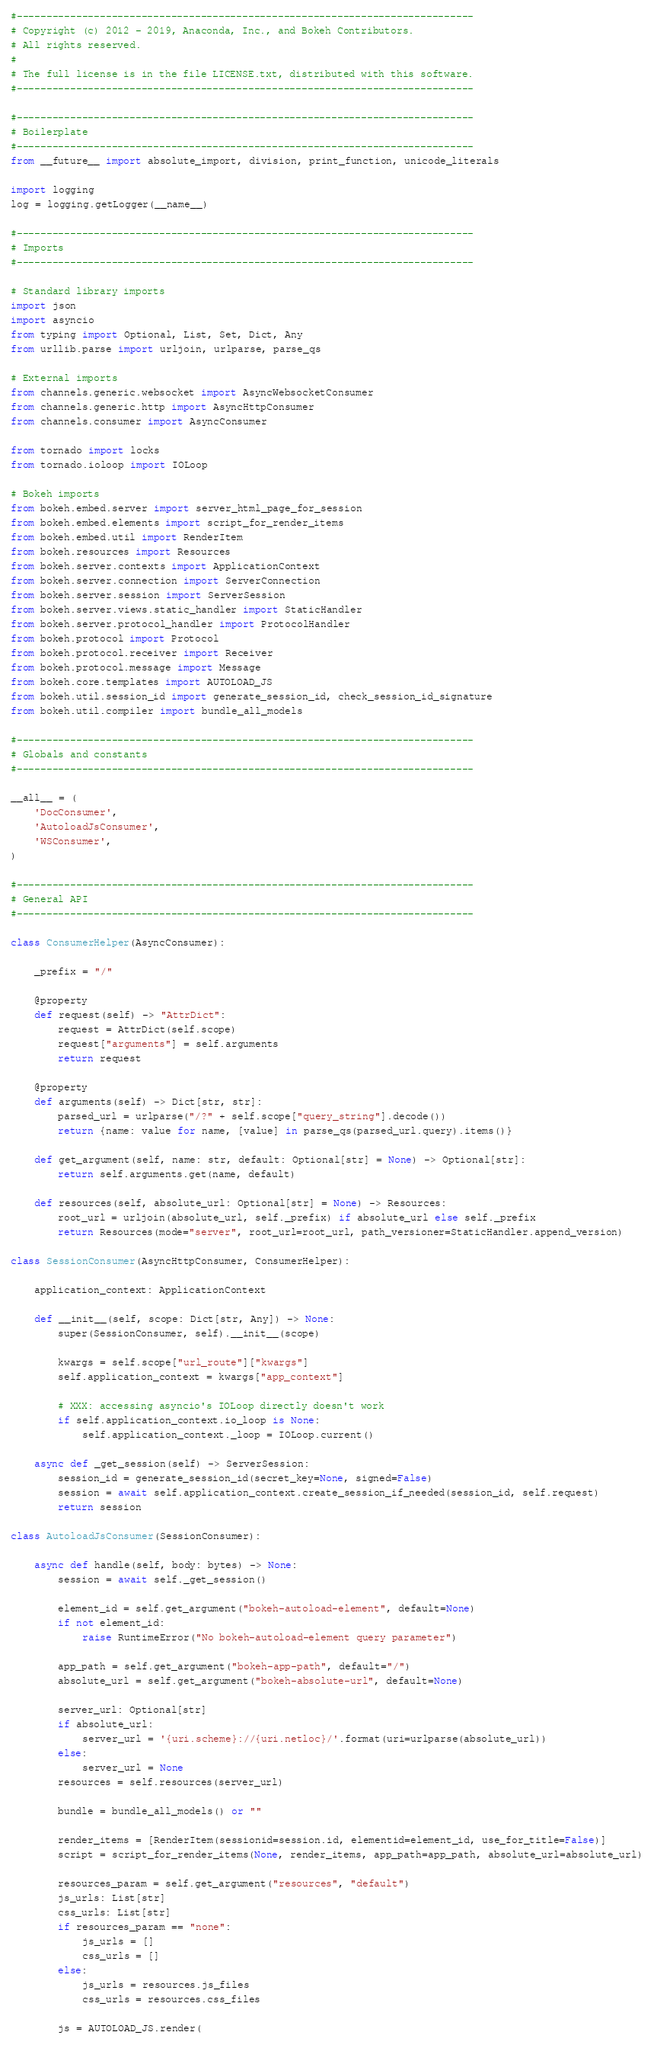Convert code to text. <code><loc_0><loc_0><loc_500><loc_500><_Python_>#-----------------------------------------------------------------------------
# Copyright (c) 2012 - 2019, Anaconda, Inc., and Bokeh Contributors.
# All rights reserved.
#
# The full license is in the file LICENSE.txt, distributed with this software.
#-----------------------------------------------------------------------------

#-----------------------------------------------------------------------------
# Boilerplate
#-----------------------------------------------------------------------------
from __future__ import absolute_import, division, print_function, unicode_literals

import logging
log = logging.getLogger(__name__)

#-----------------------------------------------------------------------------
# Imports
#-----------------------------------------------------------------------------

# Standard library imports
import json
import asyncio
from typing import Optional, List, Set, Dict, Any
from urllib.parse import urljoin, urlparse, parse_qs

# External imports
from channels.generic.websocket import AsyncWebsocketConsumer
from channels.generic.http import AsyncHttpConsumer
from channels.consumer import AsyncConsumer

from tornado import locks
from tornado.ioloop import IOLoop

# Bokeh imports
from bokeh.embed.server import server_html_page_for_session
from bokeh.embed.elements import script_for_render_items
from bokeh.embed.util import RenderItem
from bokeh.resources import Resources
from bokeh.server.contexts import ApplicationContext
from bokeh.server.connection import ServerConnection
from bokeh.server.session import ServerSession
from bokeh.server.views.static_handler import StaticHandler
from bokeh.server.protocol_handler import ProtocolHandler
from bokeh.protocol import Protocol
from bokeh.protocol.receiver import Receiver
from bokeh.protocol.message import Message
from bokeh.core.templates import AUTOLOAD_JS
from bokeh.util.session_id import generate_session_id, check_session_id_signature
from bokeh.util.compiler import bundle_all_models

#-----------------------------------------------------------------------------
# Globals and constants
#-----------------------------------------------------------------------------

__all__ = (
    'DocConsumer',
    'AutoloadJsConsumer',
    'WSConsumer',
)

#-----------------------------------------------------------------------------
# General API
#-----------------------------------------------------------------------------

class ConsumerHelper(AsyncConsumer):

    _prefix = "/"

    @property
    def request(self) -> "AttrDict":
        request = AttrDict(self.scope)
        request["arguments"] = self.arguments
        return request

    @property
    def arguments(self) -> Dict[str, str]:
        parsed_url = urlparse("/?" + self.scope["query_string"].decode())
        return {name: value for name, [value] in parse_qs(parsed_url.query).items()}

    def get_argument(self, name: str, default: Optional[str] = None) -> Optional[str]:
        return self.arguments.get(name, default)

    def resources(self, absolute_url: Optional[str] = None) -> Resources:
        root_url = urljoin(absolute_url, self._prefix) if absolute_url else self._prefix
        return Resources(mode="server", root_url=root_url, path_versioner=StaticHandler.append_version)

class SessionConsumer(AsyncHttpConsumer, ConsumerHelper):

    application_context: ApplicationContext

    def __init__(self, scope: Dict[str, Any]) -> None:
        super(SessionConsumer, self).__init__(scope)

        kwargs = self.scope["url_route"]["kwargs"]
        self.application_context = kwargs["app_context"]

        # XXX: accessing asyncio's IOLoop directly doesn't work
        if self.application_context.io_loop is None:
            self.application_context._loop = IOLoop.current()

    async def _get_session(self) -> ServerSession:
        session_id = generate_session_id(secret_key=None, signed=False)
        session = await self.application_context.create_session_if_needed(session_id, self.request)
        return session

class AutoloadJsConsumer(SessionConsumer):

    async def handle(self, body: bytes) -> None:
        session = await self._get_session()

        element_id = self.get_argument("bokeh-autoload-element", default=None)
        if not element_id:
            raise RuntimeError("No bokeh-autoload-element query parameter")

        app_path = self.get_argument("bokeh-app-path", default="/")
        absolute_url = self.get_argument("bokeh-absolute-url", default=None)

        server_url: Optional[str]
        if absolute_url:
            server_url = '{uri.scheme}://{uri.netloc}/'.format(uri=urlparse(absolute_url))
        else:
            server_url = None
        resources = self.resources(server_url)

        bundle = bundle_all_models() or ""

        render_items = [RenderItem(sessionid=session.id, elementid=element_id, use_for_title=False)]
        script = script_for_render_items(None, render_items, app_path=app_path, absolute_url=absolute_url)

        resources_param = self.get_argument("resources", "default")
        js_urls: List[str]
        css_urls: List[str]
        if resources_param == "none":
            js_urls = []
            css_urls = []
        else:
            js_urls = resources.js_files
            css_urls = resources.css_files

        js = AUTOLOAD_JS.render(</code> 